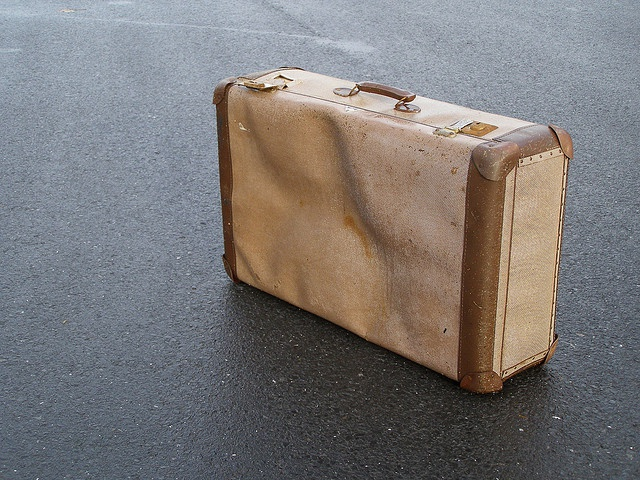Describe the objects in this image and their specific colors. I can see a suitcase in darkgray, gray, tan, and brown tones in this image. 